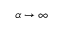Convert formula to latex. <formula><loc_0><loc_0><loc_500><loc_500>\alpha \to \infty</formula> 